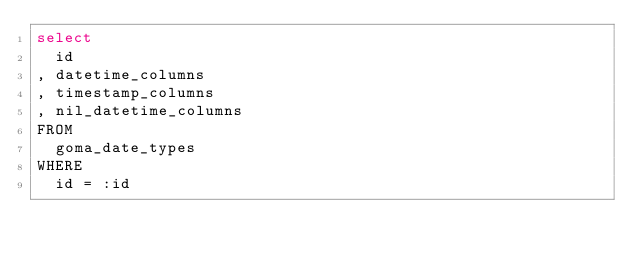Convert code to text. <code><loc_0><loc_0><loc_500><loc_500><_SQL_>select
  id
, datetime_columns
, timestamp_columns
, nil_datetime_columns
FROM
  goma_date_types
WHERE
  id = :id

</code> 